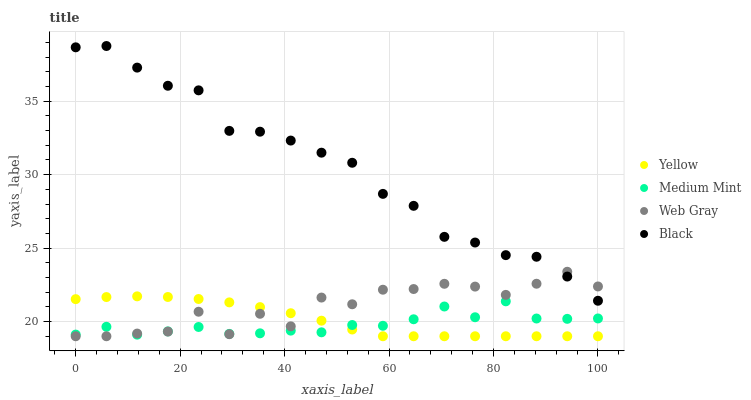Does Medium Mint have the minimum area under the curve?
Answer yes or no. Yes. Does Black have the maximum area under the curve?
Answer yes or no. Yes. Does Web Gray have the minimum area under the curve?
Answer yes or no. No. Does Web Gray have the maximum area under the curve?
Answer yes or no. No. Is Yellow the smoothest?
Answer yes or no. Yes. Is Web Gray the roughest?
Answer yes or no. Yes. Is Black the smoothest?
Answer yes or no. No. Is Black the roughest?
Answer yes or no. No. Does Web Gray have the lowest value?
Answer yes or no. Yes. Does Black have the lowest value?
Answer yes or no. No. Does Black have the highest value?
Answer yes or no. Yes. Does Web Gray have the highest value?
Answer yes or no. No. Is Yellow less than Black?
Answer yes or no. Yes. Is Black greater than Medium Mint?
Answer yes or no. Yes. Does Black intersect Web Gray?
Answer yes or no. Yes. Is Black less than Web Gray?
Answer yes or no. No. Is Black greater than Web Gray?
Answer yes or no. No. Does Yellow intersect Black?
Answer yes or no. No. 